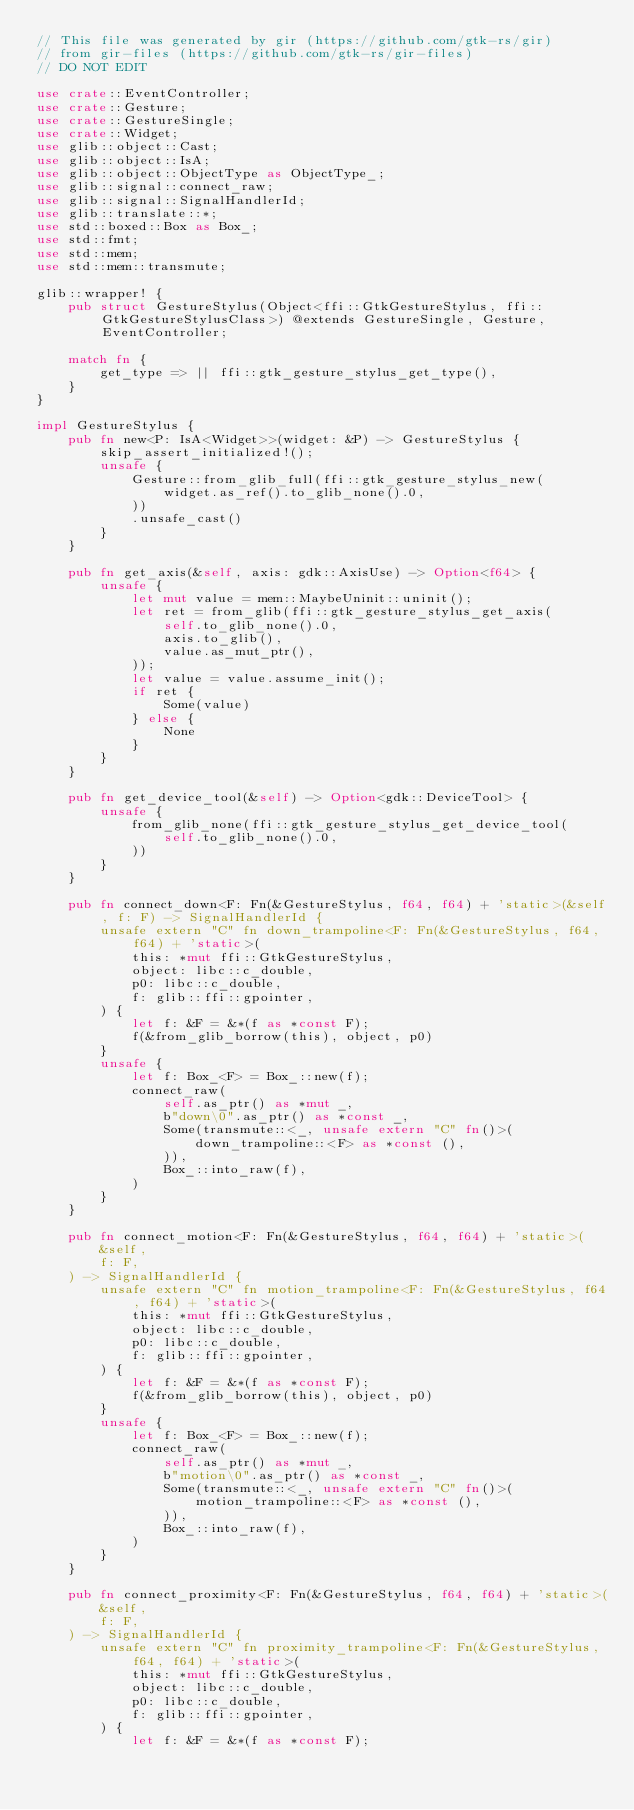<code> <loc_0><loc_0><loc_500><loc_500><_Rust_>// This file was generated by gir (https://github.com/gtk-rs/gir)
// from gir-files (https://github.com/gtk-rs/gir-files)
// DO NOT EDIT

use crate::EventController;
use crate::Gesture;
use crate::GestureSingle;
use crate::Widget;
use glib::object::Cast;
use glib::object::IsA;
use glib::object::ObjectType as ObjectType_;
use glib::signal::connect_raw;
use glib::signal::SignalHandlerId;
use glib::translate::*;
use std::boxed::Box as Box_;
use std::fmt;
use std::mem;
use std::mem::transmute;

glib::wrapper! {
    pub struct GestureStylus(Object<ffi::GtkGestureStylus, ffi::GtkGestureStylusClass>) @extends GestureSingle, Gesture, EventController;

    match fn {
        get_type => || ffi::gtk_gesture_stylus_get_type(),
    }
}

impl GestureStylus {
    pub fn new<P: IsA<Widget>>(widget: &P) -> GestureStylus {
        skip_assert_initialized!();
        unsafe {
            Gesture::from_glib_full(ffi::gtk_gesture_stylus_new(
                widget.as_ref().to_glib_none().0,
            ))
            .unsafe_cast()
        }
    }

    pub fn get_axis(&self, axis: gdk::AxisUse) -> Option<f64> {
        unsafe {
            let mut value = mem::MaybeUninit::uninit();
            let ret = from_glib(ffi::gtk_gesture_stylus_get_axis(
                self.to_glib_none().0,
                axis.to_glib(),
                value.as_mut_ptr(),
            ));
            let value = value.assume_init();
            if ret {
                Some(value)
            } else {
                None
            }
        }
    }

    pub fn get_device_tool(&self) -> Option<gdk::DeviceTool> {
        unsafe {
            from_glib_none(ffi::gtk_gesture_stylus_get_device_tool(
                self.to_glib_none().0,
            ))
        }
    }

    pub fn connect_down<F: Fn(&GestureStylus, f64, f64) + 'static>(&self, f: F) -> SignalHandlerId {
        unsafe extern "C" fn down_trampoline<F: Fn(&GestureStylus, f64, f64) + 'static>(
            this: *mut ffi::GtkGestureStylus,
            object: libc::c_double,
            p0: libc::c_double,
            f: glib::ffi::gpointer,
        ) {
            let f: &F = &*(f as *const F);
            f(&from_glib_borrow(this), object, p0)
        }
        unsafe {
            let f: Box_<F> = Box_::new(f);
            connect_raw(
                self.as_ptr() as *mut _,
                b"down\0".as_ptr() as *const _,
                Some(transmute::<_, unsafe extern "C" fn()>(
                    down_trampoline::<F> as *const (),
                )),
                Box_::into_raw(f),
            )
        }
    }

    pub fn connect_motion<F: Fn(&GestureStylus, f64, f64) + 'static>(
        &self,
        f: F,
    ) -> SignalHandlerId {
        unsafe extern "C" fn motion_trampoline<F: Fn(&GestureStylus, f64, f64) + 'static>(
            this: *mut ffi::GtkGestureStylus,
            object: libc::c_double,
            p0: libc::c_double,
            f: glib::ffi::gpointer,
        ) {
            let f: &F = &*(f as *const F);
            f(&from_glib_borrow(this), object, p0)
        }
        unsafe {
            let f: Box_<F> = Box_::new(f);
            connect_raw(
                self.as_ptr() as *mut _,
                b"motion\0".as_ptr() as *const _,
                Some(transmute::<_, unsafe extern "C" fn()>(
                    motion_trampoline::<F> as *const (),
                )),
                Box_::into_raw(f),
            )
        }
    }

    pub fn connect_proximity<F: Fn(&GestureStylus, f64, f64) + 'static>(
        &self,
        f: F,
    ) -> SignalHandlerId {
        unsafe extern "C" fn proximity_trampoline<F: Fn(&GestureStylus, f64, f64) + 'static>(
            this: *mut ffi::GtkGestureStylus,
            object: libc::c_double,
            p0: libc::c_double,
            f: glib::ffi::gpointer,
        ) {
            let f: &F = &*(f as *const F);</code> 